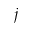<formula> <loc_0><loc_0><loc_500><loc_500>j</formula> 